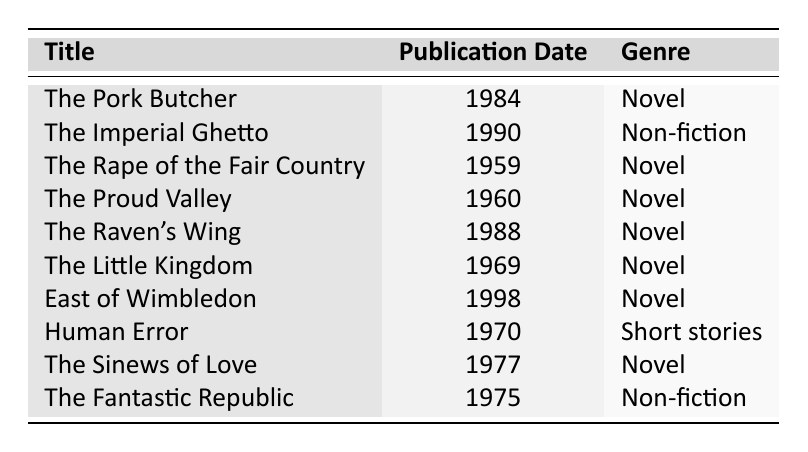What is the title of David Hughes's first published work? The first published work in the table is "The Rape of the Fair Country," which has the earliest publication date listed as 1959.
Answer: The Rape of the Fair Country In what year was "The Imperial Ghetto" published? Looking at the table, the row for "The Imperial Ghetto" shows that it was published in 1990.
Answer: 1990 How many novels did David Hughes publish? By counting the genres listed in the table, there are 7 works categorized as "Novel" out of the 10 total works.
Answer: 7 Which is the most recent publication by David Hughes? The last publication date in the table is for "East of Wimbledon," which was published in 1998, making it the most recent.
Answer: East of Wimbledon Is "Human Error" a novel? Referring to the table, "Human Error" is categorized as "Short stories," so the answer is no.
Answer: No What is the genre of "The Raven's Wing"? The table indicates that "The Raven's Wing" is categorized as a "Novel."
Answer: Novel What is the average publication year of all David Hughes's works? To calculate the average, sum all the publication years (1984 + 1990 + 1959 + 1960 + 1988 + 1969 + 1998 + 1970 + 1977 + 1975 = 1980.3). Since there are 10 works, the average is 1980.3 / 10, which rounds to 1980.
Answer: 1980 How many works published before 1980? From the table, the following works were published before 1980: "The Rape of the Fair Country," "The Proud Valley," "The Little Kingdom," "Human Error," "The Sinews of Love," and "The Fantastic Republic," totaling 6 works.
Answer: 6 Was "The Fantastic Republic" published after "The Sinews of Love"? By comparing the publication dates from the table, "The Fantastic Republic" (1975) was published before "The Sinews of Love" (1977), so the statement is false.
Answer: No Which genre was published the latest? The latest publication for a "Novel" is "East of Wimbledon" in 1998, while the latest for "Non-fiction" is "The Imperial Ghetto" in 1990; hence, "Novel" was published later.
Answer: Novel 